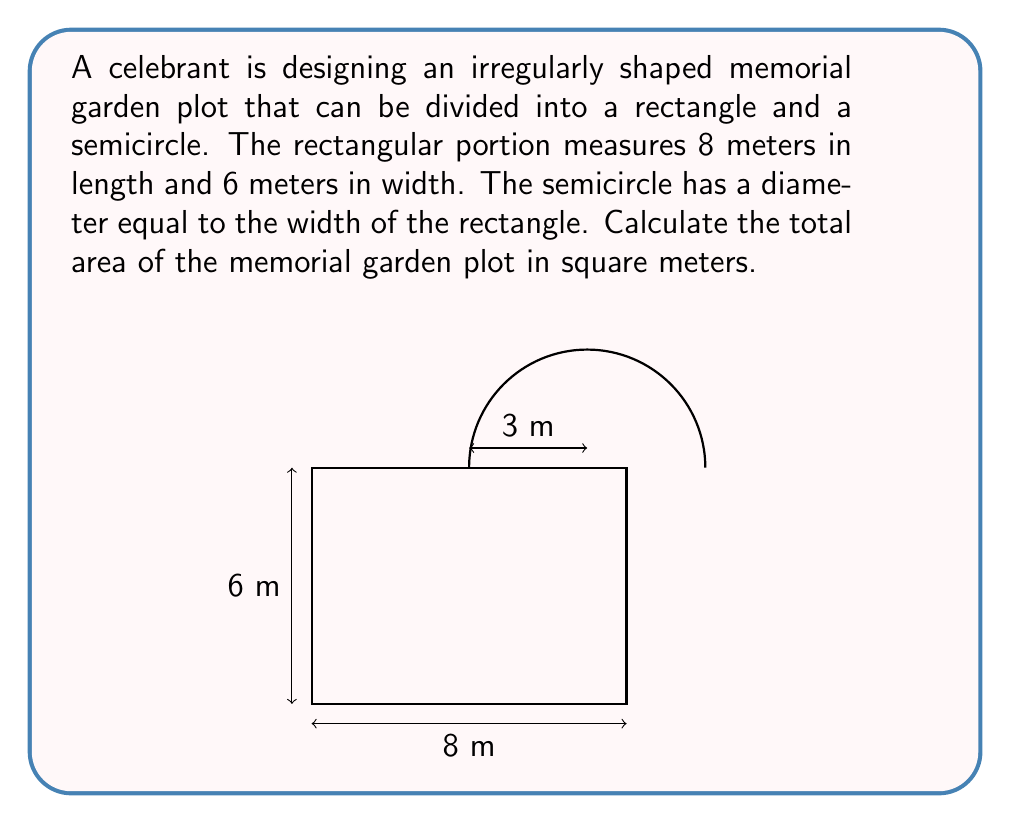Can you solve this math problem? To find the total area of the irregularly shaped memorial garden plot, we need to calculate the areas of the rectangle and semicircle separately, then add them together.

1. Area of the rectangle:
   $A_r = l \times w$
   $A_r = 8 \text{ m} \times 6 \text{ m} = 48 \text{ m}^2$

2. Area of the semicircle:
   The diameter of the semicircle is equal to the width of the rectangle, which is 6 m.
   Therefore, the radius is half of this, 3 m.
   
   Area of a full circle: $A_c = \pi r^2$
   Area of a semicircle: $A_s = \frac{1}{2} \pi r^2$
   
   $A_s = \frac{1}{2} \pi (3 \text{ m})^2 = \frac{9\pi}{2} \text{ m}^2 \approx 14.14 \text{ m}^2$

3. Total area of the memorial garden plot:
   $A_{\text{total}} = A_r + A_s$
   $A_{\text{total}} = 48 \text{ m}^2 + \frac{9\pi}{2} \text{ m}^2$
   $A_{\text{total}} = 48 + \frac{9\pi}{2} \text{ m}^2 \approx 62.14 \text{ m}^2$
Answer: $48 + \frac{9\pi}{2} \text{ m}^2 \approx 62.14 \text{ m}^2$ 